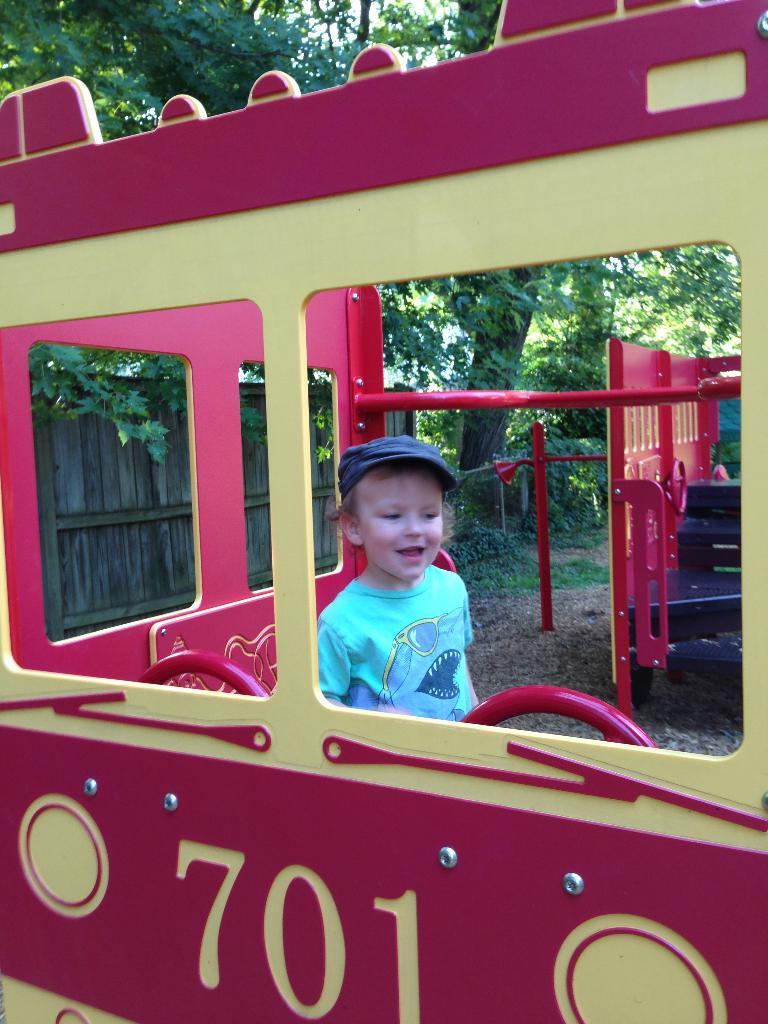What is the main subject of the image? There is a vehicle in the image. Who or what is inside the vehicle? A boy is inside the vehicle. What is the boy wearing? The boy is wearing a cap. What is an unusual feature of the vehicle's interior? There is a wooden fence inside the vehicle. What can be seen in the background of the image? Trees are visible in the image. What type of produce is being compared by the women in the image? There are no women or produce present in the image; it features a vehicle with a boy inside and a wooden fence. 